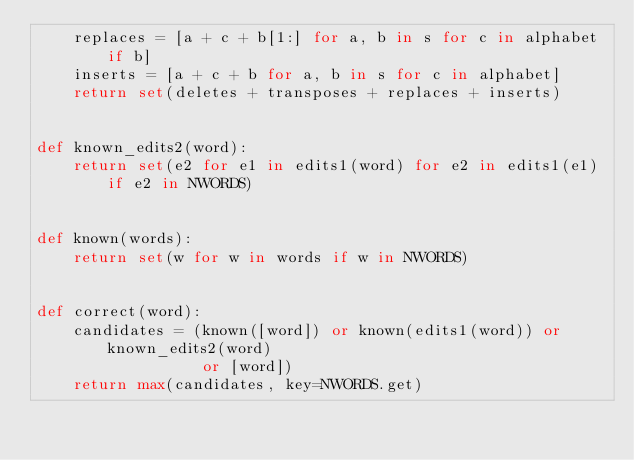Convert code to text. <code><loc_0><loc_0><loc_500><loc_500><_Python_>    replaces = [a + c + b[1:] for a, b in s for c in alphabet if b]
    inserts = [a + c + b for a, b in s for c in alphabet]
    return set(deletes + transposes + replaces + inserts)


def known_edits2(word):
    return set(e2 for e1 in edits1(word) for e2 in edits1(e1) if e2 in NWORDS)


def known(words):
    return set(w for w in words if w in NWORDS)


def correct(word):
    candidates = (known([word]) or known(edits1(word)) or known_edits2(word)
                  or [word])
    return max(candidates, key=NWORDS.get)
</code> 